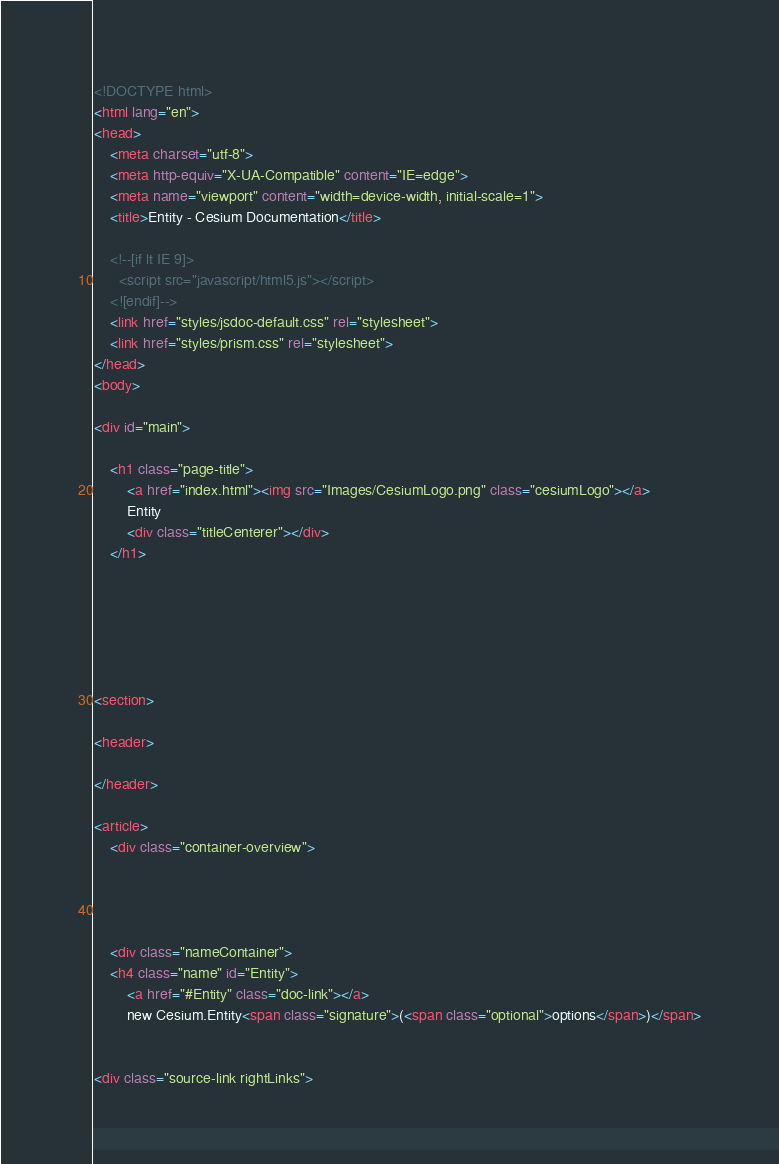Convert code to text. <code><loc_0><loc_0><loc_500><loc_500><_HTML_><!DOCTYPE html>
<html lang="en">
<head>
    <meta charset="utf-8">
    <meta http-equiv="X-UA-Compatible" content="IE=edge">
    <meta name="viewport" content="width=device-width, initial-scale=1">
    <title>Entity - Cesium Documentation</title>

    <!--[if lt IE 9]>
      <script src="javascript/html5.js"></script>
    <![endif]-->
    <link href="styles/jsdoc-default.css" rel="stylesheet">
    <link href="styles/prism.css" rel="stylesheet">
</head>
<body>

<div id="main">

    <h1 class="page-title">
        <a href="index.html"><img src="Images/CesiumLogo.png" class="cesiumLogo"></a>
        Entity
        <div class="titleCenterer"></div>
    </h1>

    




<section>

<header>
    
</header>

<article>
    <div class="container-overview">
    

    
        
    <div class="nameContainer">
    <h4 class="name" id="Entity">
        <a href="#Entity" class="doc-link"></a>
        new Cesium.Entity<span class="signature">(<span class="optional">options</span>)</span>
        

<div class="source-link rightLinks"></code> 